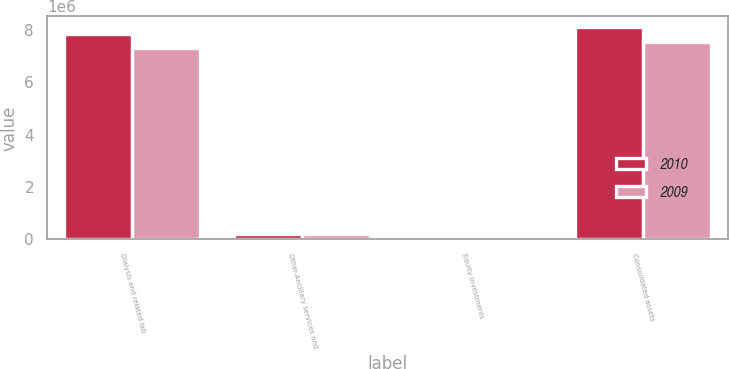Convert chart. <chart><loc_0><loc_0><loc_500><loc_500><stacked_bar_chart><ecel><fcel>Dialysis and related lab<fcel>Other-Ancillary services and<fcel>Equity investments<fcel>Consolidated assets<nl><fcel>2010<fcel>7.86288e+06<fcel>225624<fcel>25918<fcel>8.11442e+06<nl><fcel>2009<fcel>7.3116e+06<fcel>224001<fcel>22631<fcel>7.55824e+06<nl></chart> 